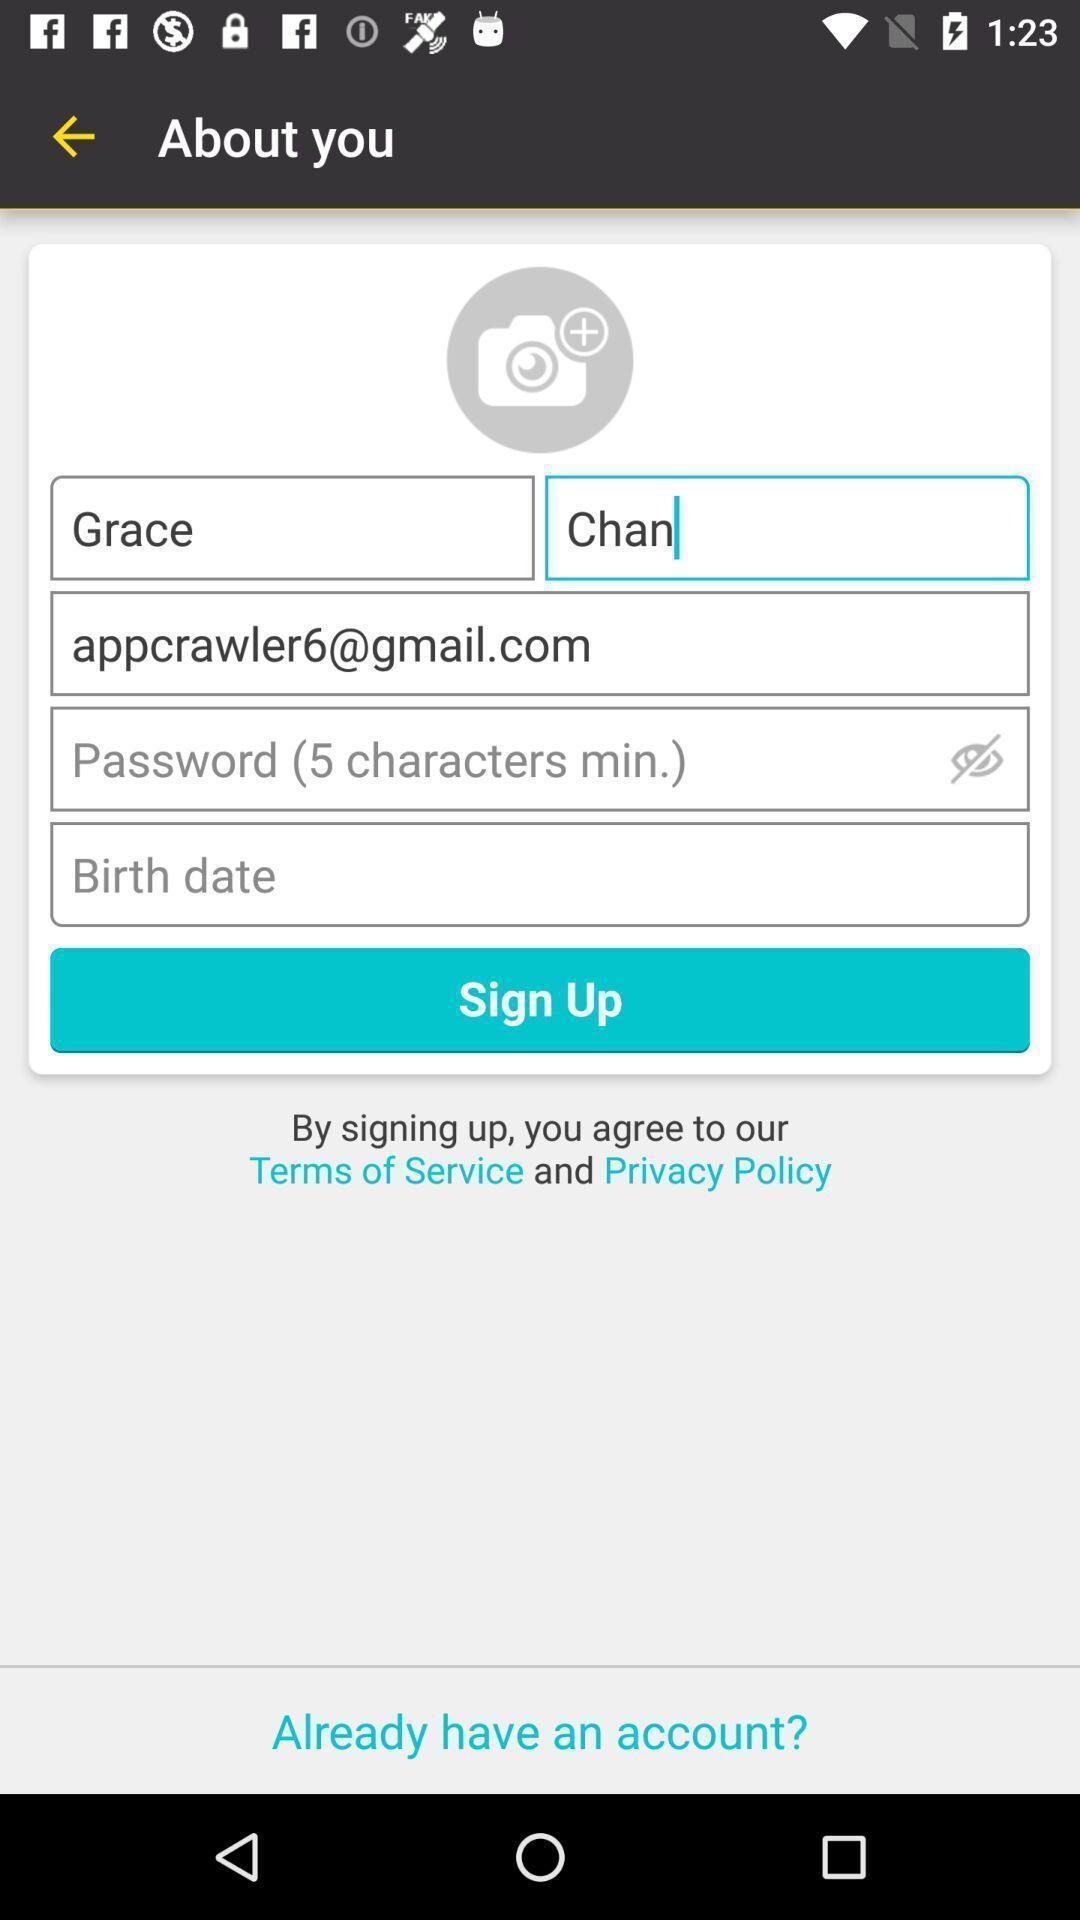Describe the visual elements of this screenshot. Sign up page. 